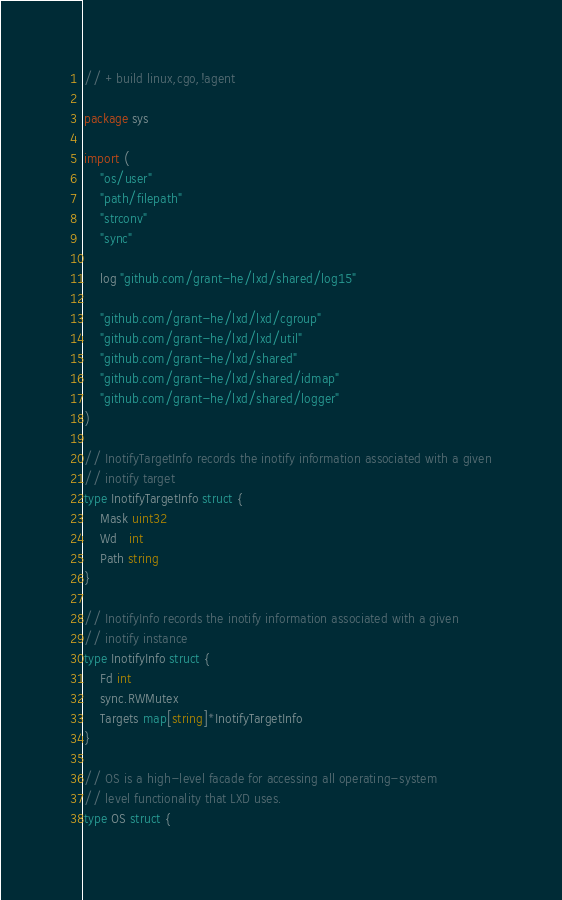Convert code to text. <code><loc_0><loc_0><loc_500><loc_500><_Go_>// +build linux,cgo,!agent

package sys

import (
	"os/user"
	"path/filepath"
	"strconv"
	"sync"

	log "github.com/grant-he/lxd/shared/log15"

	"github.com/grant-he/lxd/lxd/cgroup"
	"github.com/grant-he/lxd/lxd/util"
	"github.com/grant-he/lxd/shared"
	"github.com/grant-he/lxd/shared/idmap"
	"github.com/grant-he/lxd/shared/logger"
)

// InotifyTargetInfo records the inotify information associated with a given
// inotify target
type InotifyTargetInfo struct {
	Mask uint32
	Wd   int
	Path string
}

// InotifyInfo records the inotify information associated with a given
// inotify instance
type InotifyInfo struct {
	Fd int
	sync.RWMutex
	Targets map[string]*InotifyTargetInfo
}

// OS is a high-level facade for accessing all operating-system
// level functionality that LXD uses.
type OS struct {</code> 